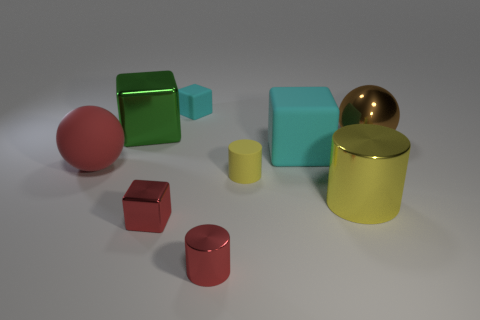Subtract all shiny cylinders. How many cylinders are left? 1 Subtract all blue balls. How many yellow cylinders are left? 2 Subtract 1 cubes. How many cubes are left? 3 Subtract all red blocks. How many blocks are left? 3 Subtract all spheres. How many objects are left? 7 Add 4 big red balls. How many big red balls are left? 5 Add 8 small yellow objects. How many small yellow objects exist? 9 Subtract 0 gray spheres. How many objects are left? 9 Subtract all gray cubes. Subtract all cyan cylinders. How many cubes are left? 4 Subtract all big balls. Subtract all small cubes. How many objects are left? 5 